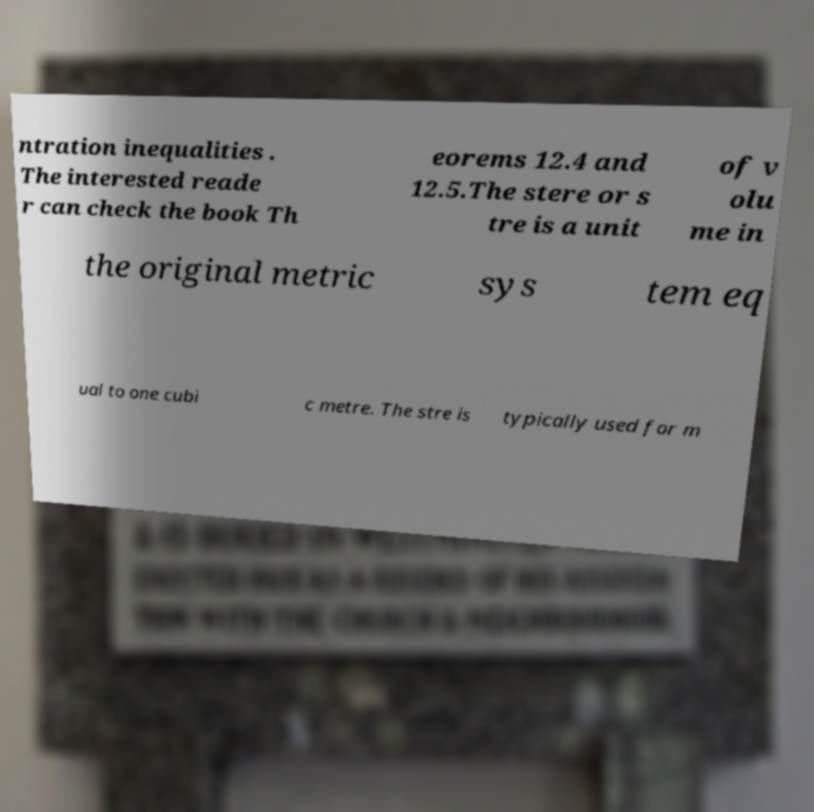Can you read and provide the text displayed in the image?This photo seems to have some interesting text. Can you extract and type it out for me? ntration inequalities . The interested reade r can check the book Th eorems 12.4 and 12.5.The stere or s tre is a unit of v olu me in the original metric sys tem eq ual to one cubi c metre. The stre is typically used for m 